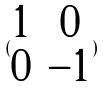<formula> <loc_0><loc_0><loc_500><loc_500>( \begin{matrix} 1 & 0 \\ 0 & - 1 \end{matrix} )</formula> 